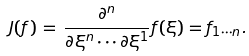<formula> <loc_0><loc_0><loc_500><loc_500>J ( f ) \, = \, \frac { \partial ^ { n } } { \partial \xi ^ { n } \cdots \partial \xi ^ { 1 } } f ( \xi ) = f _ { 1 \cdots n } .</formula> 